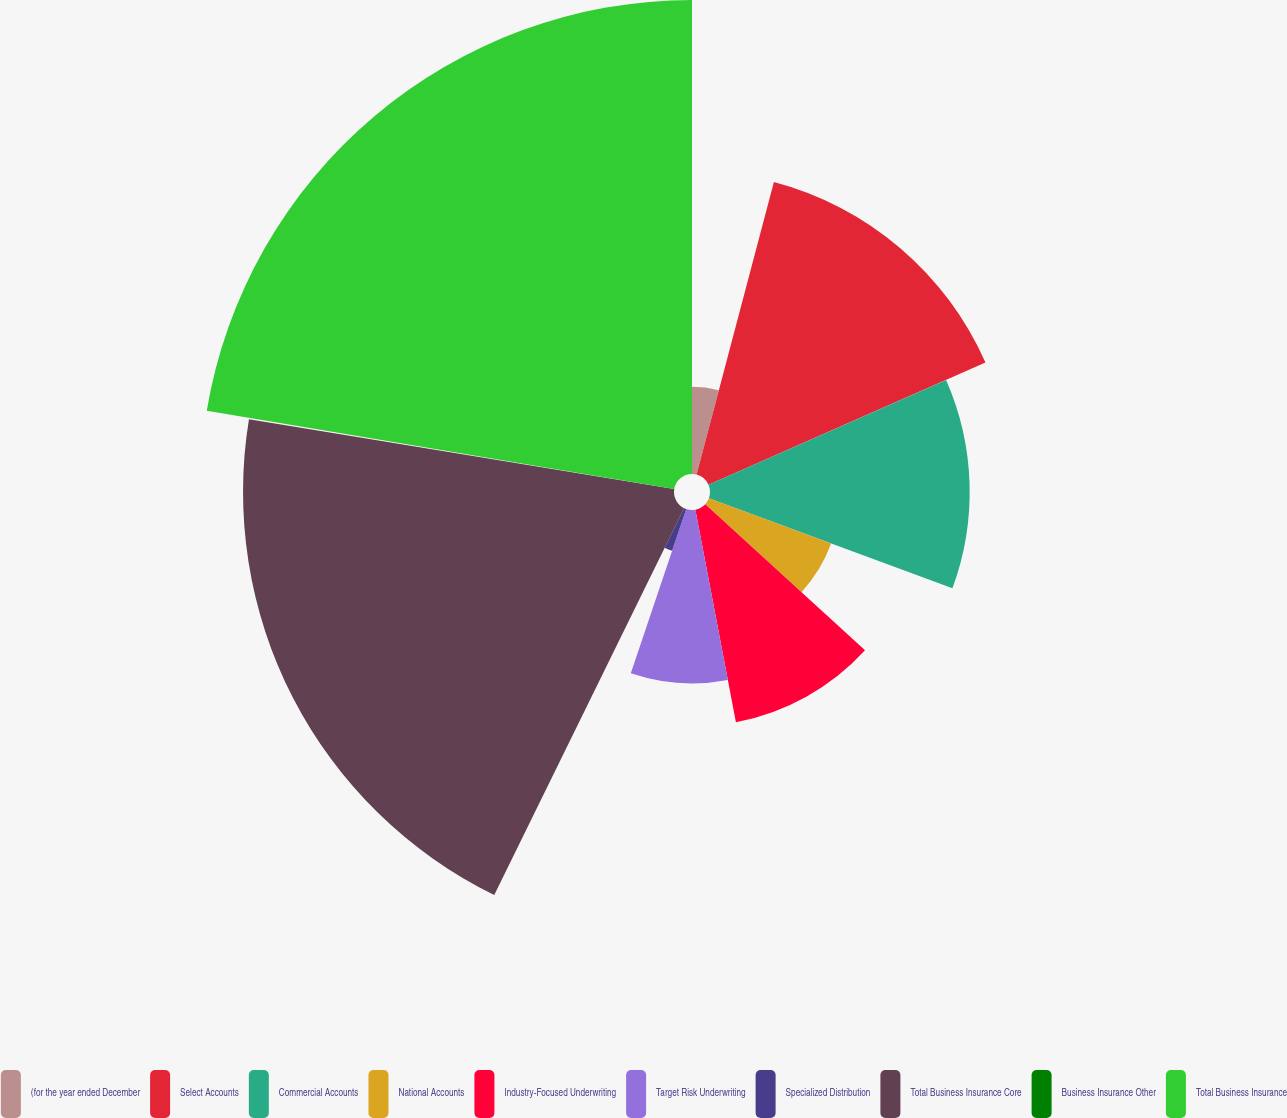Convert chart to OTSL. <chart><loc_0><loc_0><loc_500><loc_500><pie_chart><fcel>(for the year ended December<fcel>Select Accounts<fcel>Commercial Accounts<fcel>National Accounts<fcel>Industry-Focused Underwriting<fcel>Target Risk Underwriting<fcel>Specialized Distribution<fcel>Total Business Insurance Core<fcel>Business Insurance Other<fcel>Total Business Insurance<nl><fcel>4.11%<fcel>14.28%<fcel>12.25%<fcel>6.15%<fcel>10.21%<fcel>8.18%<fcel>2.08%<fcel>20.33%<fcel>0.05%<fcel>22.36%<nl></chart> 